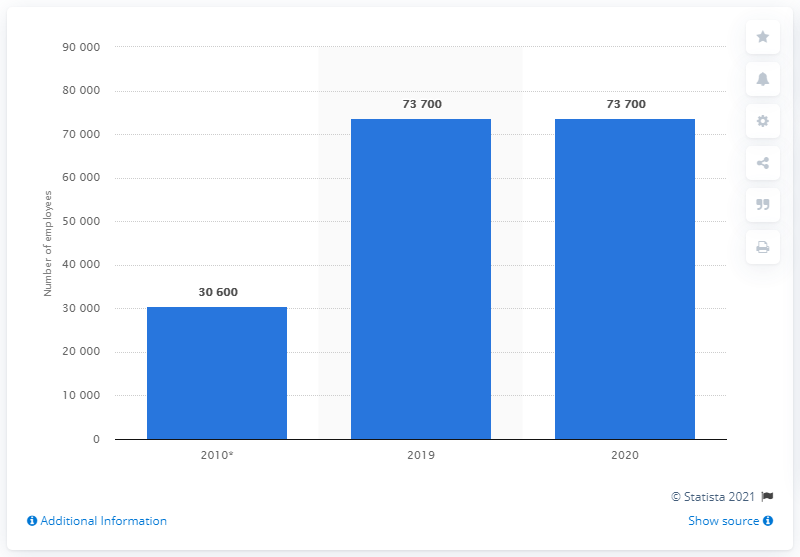Mention a couple of crucial points in this snapshot. At the end of 2020, Cigna employed a total of 73,700 people. 